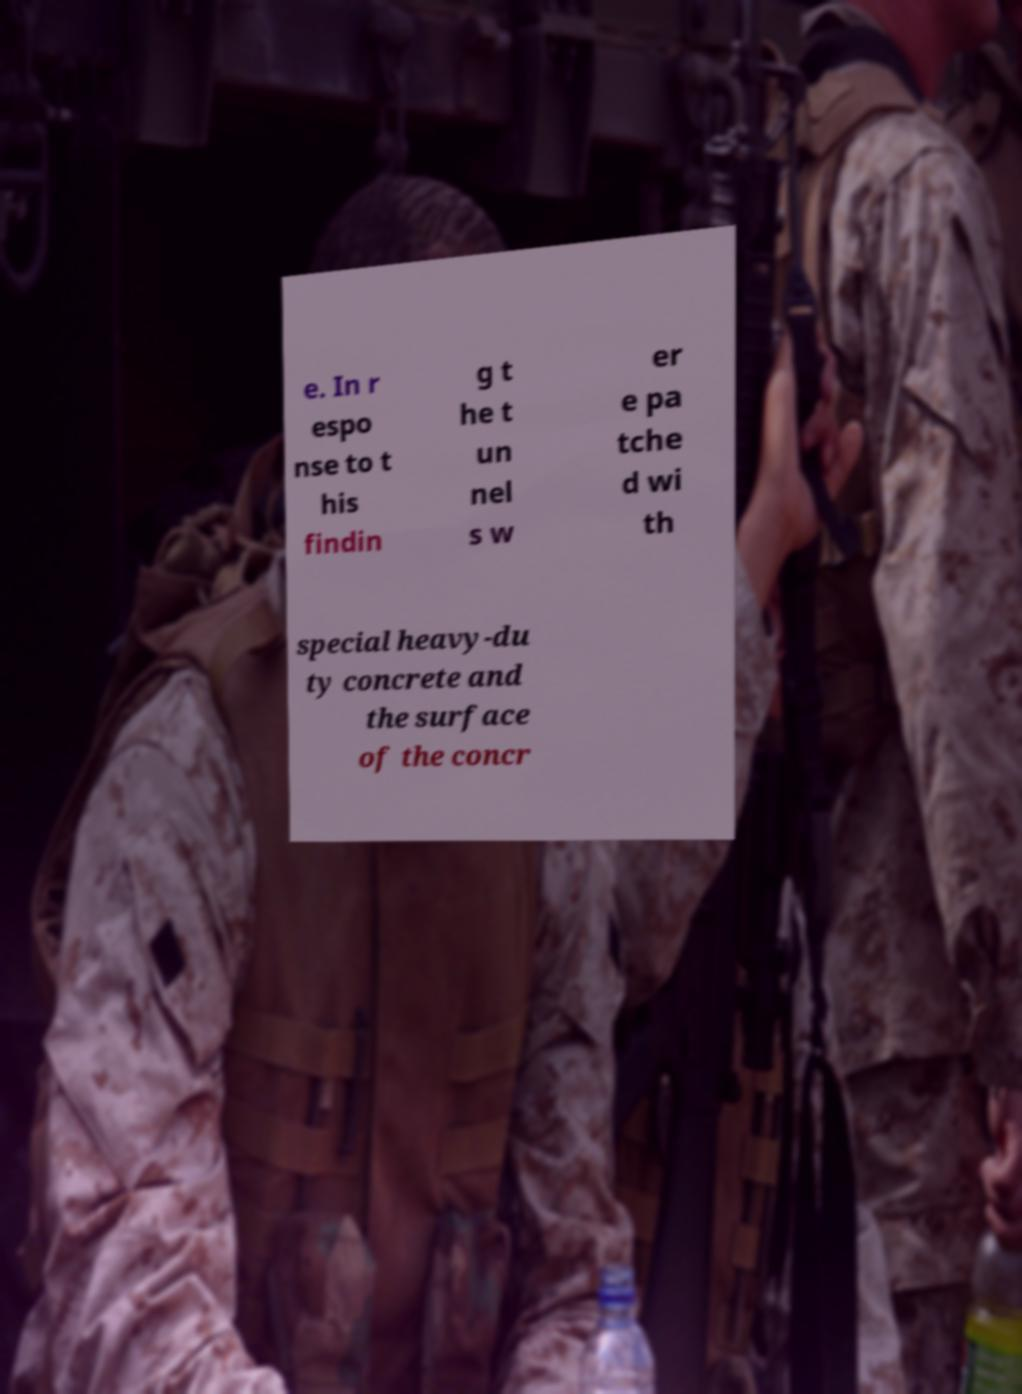I need the written content from this picture converted into text. Can you do that? e. In r espo nse to t his findin g t he t un nel s w er e pa tche d wi th special heavy-du ty concrete and the surface of the concr 